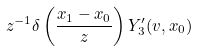<formula> <loc_0><loc_0><loc_500><loc_500>z ^ { - 1 } \delta \left ( \frac { x _ { 1 } - x _ { 0 } } { z } \right ) Y _ { 3 } ^ { \prime } ( v , x _ { 0 } )</formula> 